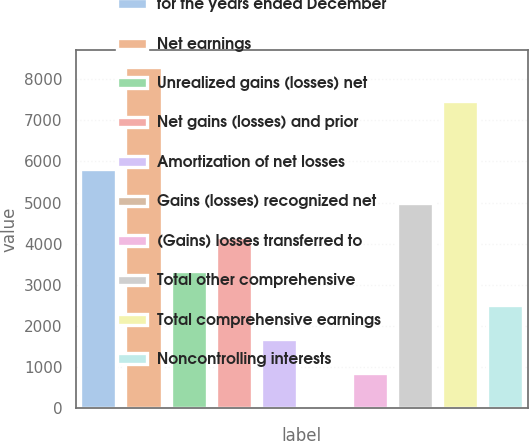<chart> <loc_0><loc_0><loc_500><loc_500><bar_chart><fcel>for the years ended December<fcel>Net earnings<fcel>Unrealized gains (losses) net<fcel>Net gains (losses) and prior<fcel>Amortization of net losses<fcel>Gains (losses) recognized net<fcel>(Gains) losses transferred to<fcel>Total other comprehensive<fcel>Total comprehensive earnings<fcel>Noncontrolling interests<nl><fcel>5807.4<fcel>8286<fcel>3328.8<fcel>4155<fcel>1676.4<fcel>24<fcel>850.2<fcel>4981.2<fcel>7459.8<fcel>2502.6<nl></chart> 